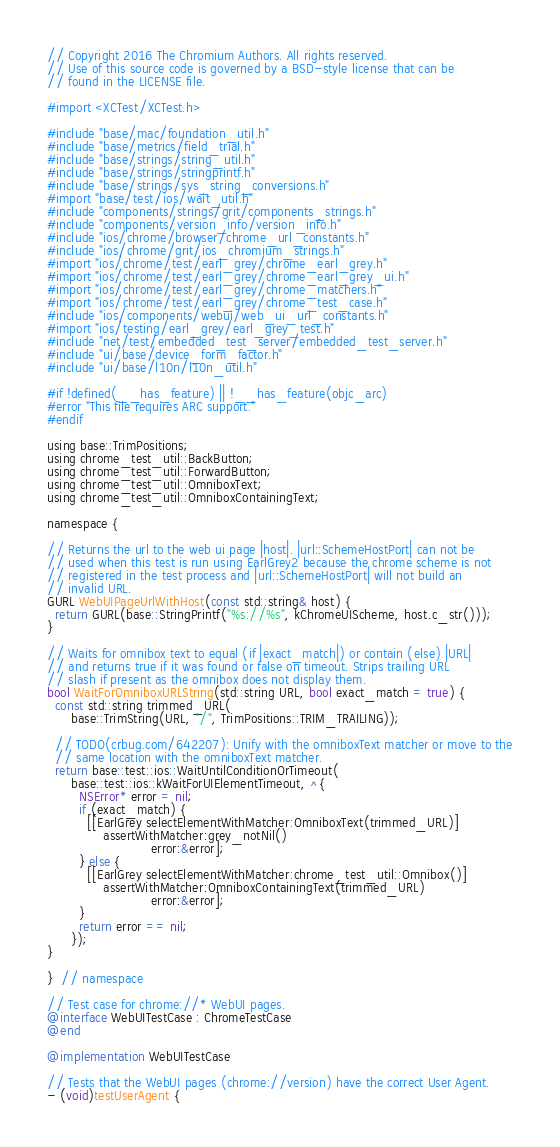<code> <loc_0><loc_0><loc_500><loc_500><_ObjectiveC_>// Copyright 2016 The Chromium Authors. All rights reserved.
// Use of this source code is governed by a BSD-style license that can be
// found in the LICENSE file.

#import <XCTest/XCTest.h>

#include "base/mac/foundation_util.h"
#include "base/metrics/field_trial.h"
#include "base/strings/string_util.h"
#include "base/strings/stringprintf.h"
#include "base/strings/sys_string_conversions.h"
#import "base/test/ios/wait_util.h"
#include "components/strings/grit/components_strings.h"
#include "components/version_info/version_info.h"
#include "ios/chrome/browser/chrome_url_constants.h"
#include "ios/chrome/grit/ios_chromium_strings.h"
#import "ios/chrome/test/earl_grey/chrome_earl_grey.h"
#import "ios/chrome/test/earl_grey/chrome_earl_grey_ui.h"
#import "ios/chrome/test/earl_grey/chrome_matchers.h"
#import "ios/chrome/test/earl_grey/chrome_test_case.h"
#include "ios/components/webui/web_ui_url_constants.h"
#import "ios/testing/earl_grey/earl_grey_test.h"
#include "net/test/embedded_test_server/embedded_test_server.h"
#include "ui/base/device_form_factor.h"
#include "ui/base/l10n/l10n_util.h"

#if !defined(__has_feature) || !__has_feature(objc_arc)
#error "This file requires ARC support."
#endif

using base::TrimPositions;
using chrome_test_util::BackButton;
using chrome_test_util::ForwardButton;
using chrome_test_util::OmniboxText;
using chrome_test_util::OmniboxContainingText;

namespace {

// Returns the url to the web ui page |host|. |url::SchemeHostPort| can not be
// used when this test is run using EarlGrey2 because the chrome scheme is not
// registered in the test process and |url::SchemeHostPort| will not build an
// invalid URL.
GURL WebUIPageUrlWithHost(const std::string& host) {
  return GURL(base::StringPrintf("%s://%s", kChromeUIScheme, host.c_str()));
}

// Waits for omnibox text to equal (if |exact_match|) or contain (else) |URL|
// and returns true if it was found or false on timeout. Strips trailing URL
// slash if present as the omnibox does not display them.
bool WaitForOmniboxURLString(std::string URL, bool exact_match = true) {
  const std::string trimmed_URL(
      base::TrimString(URL, "/", TrimPositions::TRIM_TRAILING));

  // TODO(crbug.com/642207): Unify with the omniboxText matcher or move to the
  // same location with the omniboxText matcher.
  return base::test::ios::WaitUntilConditionOrTimeout(
      base::test::ios::kWaitForUIElementTimeout, ^{
        NSError* error = nil;
        if (exact_match) {
          [[EarlGrey selectElementWithMatcher:OmniboxText(trimmed_URL)]
              assertWithMatcher:grey_notNil()
                          error:&error];
        } else {
          [[EarlGrey selectElementWithMatcher:chrome_test_util::Omnibox()]
              assertWithMatcher:OmniboxContainingText(trimmed_URL)
                          error:&error];
        }
        return error == nil;
      });
}

}  // namespace

// Test case for chrome://* WebUI pages.
@interface WebUITestCase : ChromeTestCase
@end

@implementation WebUITestCase

// Tests that the WebUI pages (chrome://version) have the correct User Agent.
- (void)testUserAgent {</code> 